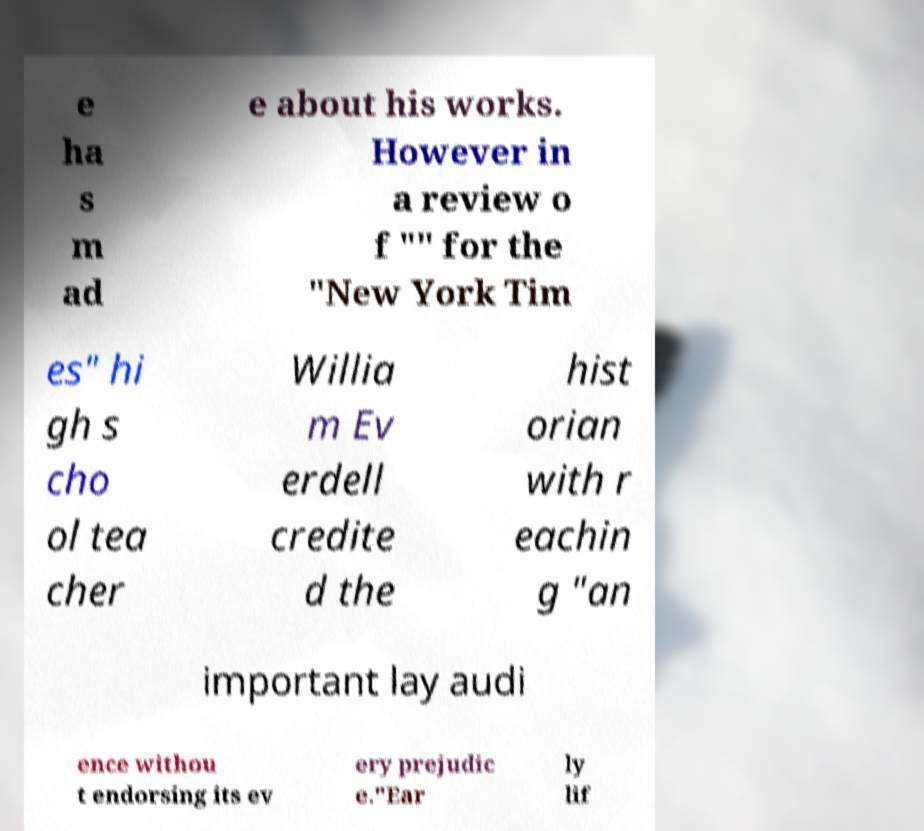I need the written content from this picture converted into text. Can you do that? e ha s m ad e about his works. However in a review o f "" for the "New York Tim es" hi gh s cho ol tea cher Willia m Ev erdell credite d the hist orian with r eachin g "an important lay audi ence withou t endorsing its ev ery prejudic e."Ear ly lif 